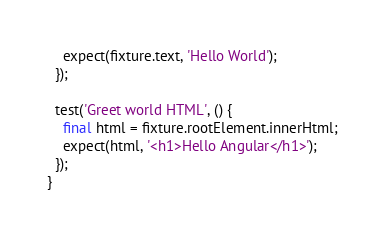Convert code to text. <code><loc_0><loc_0><loc_500><loc_500><_Dart_>    expect(fixture.text, 'Hello World');
  });

  test('Greet world HTML', () {
    final html = fixture.rootElement.innerHtml;
    expect(html, '<h1>Hello Angular</h1>');
  });
}
</code> 